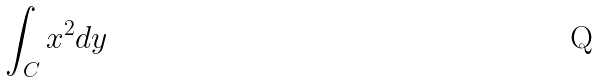Convert formula to latex. <formula><loc_0><loc_0><loc_500><loc_500>\int _ { C } x ^ { 2 } d y</formula> 